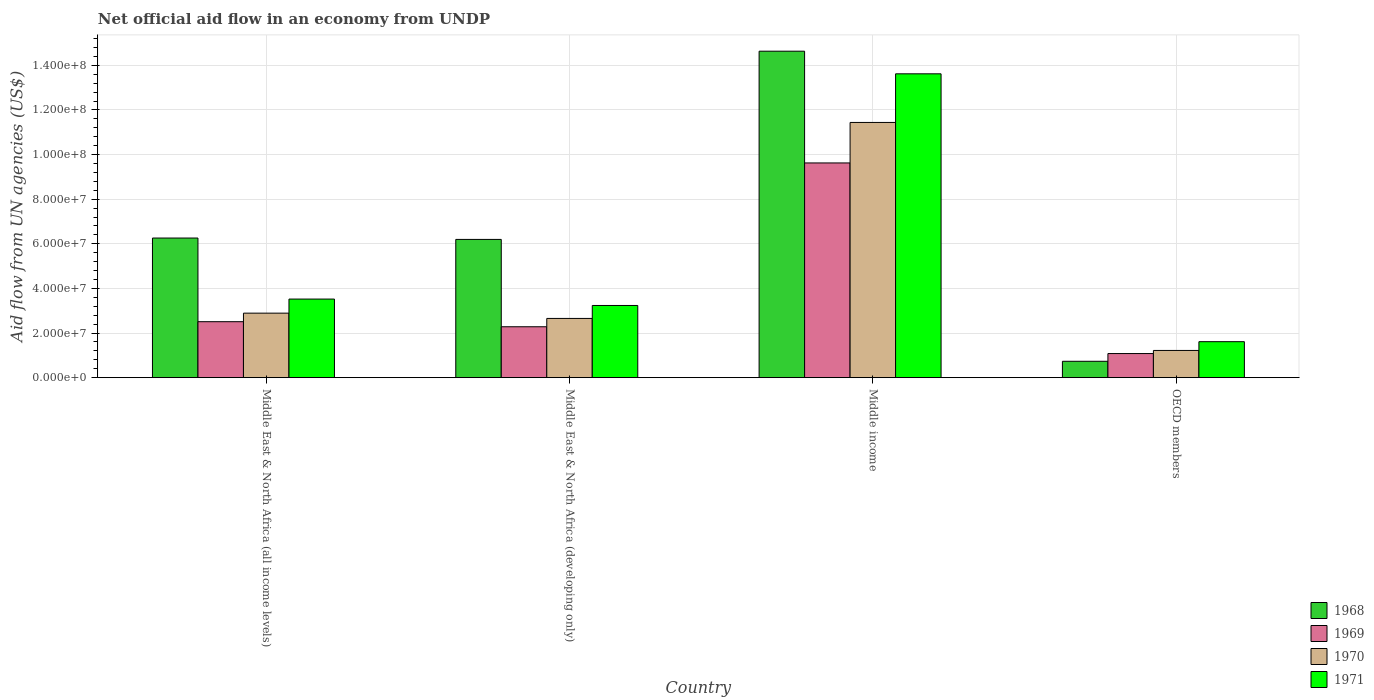How many different coloured bars are there?
Your answer should be compact. 4. Are the number of bars per tick equal to the number of legend labels?
Your answer should be very brief. Yes. How many bars are there on the 3rd tick from the right?
Your answer should be compact. 4. What is the label of the 3rd group of bars from the left?
Your answer should be compact. Middle income. What is the net official aid flow in 1968 in OECD members?
Ensure brevity in your answer.  7.34e+06. Across all countries, what is the maximum net official aid flow in 1969?
Your response must be concise. 9.62e+07. Across all countries, what is the minimum net official aid flow in 1970?
Make the answer very short. 1.22e+07. In which country was the net official aid flow in 1971 minimum?
Make the answer very short. OECD members. What is the total net official aid flow in 1970 in the graph?
Your response must be concise. 1.82e+08. What is the difference between the net official aid flow in 1970 in Middle East & North Africa (all income levels) and that in Middle income?
Provide a succinct answer. -8.55e+07. What is the difference between the net official aid flow in 1968 in Middle East & North Africa (developing only) and the net official aid flow in 1970 in Middle income?
Your answer should be compact. -5.24e+07. What is the average net official aid flow in 1969 per country?
Provide a succinct answer. 3.87e+07. What is the difference between the net official aid flow of/in 1968 and net official aid flow of/in 1970 in Middle East & North Africa (developing only)?
Your response must be concise. 3.54e+07. What is the ratio of the net official aid flow in 1968 in Middle East & North Africa (all income levels) to that in Middle income?
Your answer should be compact. 0.43. Is the net official aid flow in 1968 in Middle income less than that in OECD members?
Your answer should be very brief. No. What is the difference between the highest and the second highest net official aid flow in 1969?
Your answer should be compact. 7.34e+07. What is the difference between the highest and the lowest net official aid flow in 1969?
Make the answer very short. 8.54e+07. Is it the case that in every country, the sum of the net official aid flow in 1970 and net official aid flow in 1971 is greater than the sum of net official aid flow in 1968 and net official aid flow in 1969?
Keep it short and to the point. No. What does the 2nd bar from the left in Middle East & North Africa (developing only) represents?
Offer a very short reply. 1969. What does the 3rd bar from the right in Middle East & North Africa (all income levels) represents?
Your answer should be very brief. 1969. How many bars are there?
Your response must be concise. 16. Are all the bars in the graph horizontal?
Your response must be concise. No. How many countries are there in the graph?
Your answer should be compact. 4. What is the difference between two consecutive major ticks on the Y-axis?
Give a very brief answer. 2.00e+07. Does the graph contain any zero values?
Keep it short and to the point. No. Where does the legend appear in the graph?
Make the answer very short. Bottom right. What is the title of the graph?
Provide a short and direct response. Net official aid flow in an economy from UNDP. What is the label or title of the X-axis?
Make the answer very short. Country. What is the label or title of the Y-axis?
Ensure brevity in your answer.  Aid flow from UN agencies (US$). What is the Aid flow from UN agencies (US$) of 1968 in Middle East & North Africa (all income levels)?
Ensure brevity in your answer.  6.26e+07. What is the Aid flow from UN agencies (US$) of 1969 in Middle East & North Africa (all income levels)?
Your answer should be compact. 2.51e+07. What is the Aid flow from UN agencies (US$) of 1970 in Middle East & North Africa (all income levels)?
Offer a terse response. 2.89e+07. What is the Aid flow from UN agencies (US$) of 1971 in Middle East & North Africa (all income levels)?
Your response must be concise. 3.52e+07. What is the Aid flow from UN agencies (US$) of 1968 in Middle East & North Africa (developing only)?
Keep it short and to the point. 6.20e+07. What is the Aid flow from UN agencies (US$) in 1969 in Middle East & North Africa (developing only)?
Your answer should be compact. 2.28e+07. What is the Aid flow from UN agencies (US$) in 1970 in Middle East & North Africa (developing only)?
Your answer should be very brief. 2.66e+07. What is the Aid flow from UN agencies (US$) of 1971 in Middle East & North Africa (developing only)?
Provide a succinct answer. 3.24e+07. What is the Aid flow from UN agencies (US$) of 1968 in Middle income?
Offer a terse response. 1.46e+08. What is the Aid flow from UN agencies (US$) in 1969 in Middle income?
Make the answer very short. 9.62e+07. What is the Aid flow from UN agencies (US$) of 1970 in Middle income?
Ensure brevity in your answer.  1.14e+08. What is the Aid flow from UN agencies (US$) in 1971 in Middle income?
Offer a very short reply. 1.36e+08. What is the Aid flow from UN agencies (US$) of 1968 in OECD members?
Keep it short and to the point. 7.34e+06. What is the Aid flow from UN agencies (US$) in 1969 in OECD members?
Your response must be concise. 1.08e+07. What is the Aid flow from UN agencies (US$) of 1970 in OECD members?
Your response must be concise. 1.22e+07. What is the Aid flow from UN agencies (US$) in 1971 in OECD members?
Give a very brief answer. 1.61e+07. Across all countries, what is the maximum Aid flow from UN agencies (US$) in 1968?
Your answer should be compact. 1.46e+08. Across all countries, what is the maximum Aid flow from UN agencies (US$) in 1969?
Your answer should be compact. 9.62e+07. Across all countries, what is the maximum Aid flow from UN agencies (US$) of 1970?
Keep it short and to the point. 1.14e+08. Across all countries, what is the maximum Aid flow from UN agencies (US$) of 1971?
Provide a succinct answer. 1.36e+08. Across all countries, what is the minimum Aid flow from UN agencies (US$) of 1968?
Your answer should be compact. 7.34e+06. Across all countries, what is the minimum Aid flow from UN agencies (US$) in 1969?
Give a very brief answer. 1.08e+07. Across all countries, what is the minimum Aid flow from UN agencies (US$) of 1970?
Give a very brief answer. 1.22e+07. Across all countries, what is the minimum Aid flow from UN agencies (US$) of 1971?
Your answer should be very brief. 1.61e+07. What is the total Aid flow from UN agencies (US$) in 1968 in the graph?
Make the answer very short. 2.78e+08. What is the total Aid flow from UN agencies (US$) in 1969 in the graph?
Make the answer very short. 1.55e+08. What is the total Aid flow from UN agencies (US$) of 1970 in the graph?
Offer a terse response. 1.82e+08. What is the total Aid flow from UN agencies (US$) in 1971 in the graph?
Offer a very short reply. 2.20e+08. What is the difference between the Aid flow from UN agencies (US$) in 1968 in Middle East & North Africa (all income levels) and that in Middle East & North Africa (developing only)?
Offer a terse response. 6.20e+05. What is the difference between the Aid flow from UN agencies (US$) in 1969 in Middle East & North Africa (all income levels) and that in Middle East & North Africa (developing only)?
Offer a very short reply. 2.27e+06. What is the difference between the Aid flow from UN agencies (US$) of 1970 in Middle East & North Africa (all income levels) and that in Middle East & North Africa (developing only)?
Your response must be concise. 2.37e+06. What is the difference between the Aid flow from UN agencies (US$) in 1971 in Middle East & North Africa (all income levels) and that in Middle East & North Africa (developing only)?
Your answer should be very brief. 2.87e+06. What is the difference between the Aid flow from UN agencies (US$) of 1968 in Middle East & North Africa (all income levels) and that in Middle income?
Ensure brevity in your answer.  -8.38e+07. What is the difference between the Aid flow from UN agencies (US$) in 1969 in Middle East & North Africa (all income levels) and that in Middle income?
Give a very brief answer. -7.12e+07. What is the difference between the Aid flow from UN agencies (US$) of 1970 in Middle East & North Africa (all income levels) and that in Middle income?
Offer a very short reply. -8.55e+07. What is the difference between the Aid flow from UN agencies (US$) of 1971 in Middle East & North Africa (all income levels) and that in Middle income?
Give a very brief answer. -1.01e+08. What is the difference between the Aid flow from UN agencies (US$) in 1968 in Middle East & North Africa (all income levels) and that in OECD members?
Give a very brief answer. 5.52e+07. What is the difference between the Aid flow from UN agencies (US$) in 1969 in Middle East & North Africa (all income levels) and that in OECD members?
Make the answer very short. 1.43e+07. What is the difference between the Aid flow from UN agencies (US$) of 1970 in Middle East & North Africa (all income levels) and that in OECD members?
Your answer should be very brief. 1.67e+07. What is the difference between the Aid flow from UN agencies (US$) of 1971 in Middle East & North Africa (all income levels) and that in OECD members?
Ensure brevity in your answer.  1.91e+07. What is the difference between the Aid flow from UN agencies (US$) in 1968 in Middle East & North Africa (developing only) and that in Middle income?
Your answer should be compact. -8.44e+07. What is the difference between the Aid flow from UN agencies (US$) in 1969 in Middle East & North Africa (developing only) and that in Middle income?
Your response must be concise. -7.34e+07. What is the difference between the Aid flow from UN agencies (US$) in 1970 in Middle East & North Africa (developing only) and that in Middle income?
Your answer should be very brief. -8.78e+07. What is the difference between the Aid flow from UN agencies (US$) in 1971 in Middle East & North Africa (developing only) and that in Middle income?
Offer a very short reply. -1.04e+08. What is the difference between the Aid flow from UN agencies (US$) of 1968 in Middle East & North Africa (developing only) and that in OECD members?
Your answer should be very brief. 5.46e+07. What is the difference between the Aid flow from UN agencies (US$) of 1969 in Middle East & North Africa (developing only) and that in OECD members?
Provide a short and direct response. 1.20e+07. What is the difference between the Aid flow from UN agencies (US$) in 1970 in Middle East & North Africa (developing only) and that in OECD members?
Provide a short and direct response. 1.44e+07. What is the difference between the Aid flow from UN agencies (US$) in 1971 in Middle East & North Africa (developing only) and that in OECD members?
Provide a short and direct response. 1.62e+07. What is the difference between the Aid flow from UN agencies (US$) of 1968 in Middle income and that in OECD members?
Your answer should be very brief. 1.39e+08. What is the difference between the Aid flow from UN agencies (US$) of 1969 in Middle income and that in OECD members?
Provide a short and direct response. 8.54e+07. What is the difference between the Aid flow from UN agencies (US$) in 1970 in Middle income and that in OECD members?
Your answer should be compact. 1.02e+08. What is the difference between the Aid flow from UN agencies (US$) of 1971 in Middle income and that in OECD members?
Offer a very short reply. 1.20e+08. What is the difference between the Aid flow from UN agencies (US$) in 1968 in Middle East & North Africa (all income levels) and the Aid flow from UN agencies (US$) in 1969 in Middle East & North Africa (developing only)?
Provide a short and direct response. 3.98e+07. What is the difference between the Aid flow from UN agencies (US$) in 1968 in Middle East & North Africa (all income levels) and the Aid flow from UN agencies (US$) in 1970 in Middle East & North Africa (developing only)?
Ensure brevity in your answer.  3.60e+07. What is the difference between the Aid flow from UN agencies (US$) in 1968 in Middle East & North Africa (all income levels) and the Aid flow from UN agencies (US$) in 1971 in Middle East & North Africa (developing only)?
Ensure brevity in your answer.  3.02e+07. What is the difference between the Aid flow from UN agencies (US$) of 1969 in Middle East & North Africa (all income levels) and the Aid flow from UN agencies (US$) of 1970 in Middle East & North Africa (developing only)?
Offer a very short reply. -1.46e+06. What is the difference between the Aid flow from UN agencies (US$) in 1969 in Middle East & North Africa (all income levels) and the Aid flow from UN agencies (US$) in 1971 in Middle East & North Africa (developing only)?
Your answer should be very brief. -7.27e+06. What is the difference between the Aid flow from UN agencies (US$) of 1970 in Middle East & North Africa (all income levels) and the Aid flow from UN agencies (US$) of 1971 in Middle East & North Africa (developing only)?
Offer a terse response. -3.44e+06. What is the difference between the Aid flow from UN agencies (US$) of 1968 in Middle East & North Africa (all income levels) and the Aid flow from UN agencies (US$) of 1969 in Middle income?
Give a very brief answer. -3.37e+07. What is the difference between the Aid flow from UN agencies (US$) of 1968 in Middle East & North Africa (all income levels) and the Aid flow from UN agencies (US$) of 1970 in Middle income?
Make the answer very short. -5.18e+07. What is the difference between the Aid flow from UN agencies (US$) in 1968 in Middle East & North Africa (all income levels) and the Aid flow from UN agencies (US$) in 1971 in Middle income?
Ensure brevity in your answer.  -7.36e+07. What is the difference between the Aid flow from UN agencies (US$) in 1969 in Middle East & North Africa (all income levels) and the Aid flow from UN agencies (US$) in 1970 in Middle income?
Offer a terse response. -8.93e+07. What is the difference between the Aid flow from UN agencies (US$) of 1969 in Middle East & North Africa (all income levels) and the Aid flow from UN agencies (US$) of 1971 in Middle income?
Your answer should be compact. -1.11e+08. What is the difference between the Aid flow from UN agencies (US$) in 1970 in Middle East & North Africa (all income levels) and the Aid flow from UN agencies (US$) in 1971 in Middle income?
Make the answer very short. -1.07e+08. What is the difference between the Aid flow from UN agencies (US$) in 1968 in Middle East & North Africa (all income levels) and the Aid flow from UN agencies (US$) in 1969 in OECD members?
Offer a terse response. 5.18e+07. What is the difference between the Aid flow from UN agencies (US$) in 1968 in Middle East & North Africa (all income levels) and the Aid flow from UN agencies (US$) in 1970 in OECD members?
Give a very brief answer. 5.04e+07. What is the difference between the Aid flow from UN agencies (US$) in 1968 in Middle East & North Africa (all income levels) and the Aid flow from UN agencies (US$) in 1971 in OECD members?
Provide a short and direct response. 4.65e+07. What is the difference between the Aid flow from UN agencies (US$) in 1969 in Middle East & North Africa (all income levels) and the Aid flow from UN agencies (US$) in 1970 in OECD members?
Ensure brevity in your answer.  1.29e+07. What is the difference between the Aid flow from UN agencies (US$) of 1969 in Middle East & North Africa (all income levels) and the Aid flow from UN agencies (US$) of 1971 in OECD members?
Ensure brevity in your answer.  8.96e+06. What is the difference between the Aid flow from UN agencies (US$) of 1970 in Middle East & North Africa (all income levels) and the Aid flow from UN agencies (US$) of 1971 in OECD members?
Offer a terse response. 1.28e+07. What is the difference between the Aid flow from UN agencies (US$) of 1968 in Middle East & North Africa (developing only) and the Aid flow from UN agencies (US$) of 1969 in Middle income?
Offer a terse response. -3.43e+07. What is the difference between the Aid flow from UN agencies (US$) of 1968 in Middle East & North Africa (developing only) and the Aid flow from UN agencies (US$) of 1970 in Middle income?
Ensure brevity in your answer.  -5.24e+07. What is the difference between the Aid flow from UN agencies (US$) in 1968 in Middle East & North Africa (developing only) and the Aid flow from UN agencies (US$) in 1971 in Middle income?
Give a very brief answer. -7.42e+07. What is the difference between the Aid flow from UN agencies (US$) in 1969 in Middle East & North Africa (developing only) and the Aid flow from UN agencies (US$) in 1970 in Middle income?
Offer a very short reply. -9.16e+07. What is the difference between the Aid flow from UN agencies (US$) in 1969 in Middle East & North Africa (developing only) and the Aid flow from UN agencies (US$) in 1971 in Middle income?
Make the answer very short. -1.13e+08. What is the difference between the Aid flow from UN agencies (US$) of 1970 in Middle East & North Africa (developing only) and the Aid flow from UN agencies (US$) of 1971 in Middle income?
Keep it short and to the point. -1.10e+08. What is the difference between the Aid flow from UN agencies (US$) of 1968 in Middle East & North Africa (developing only) and the Aid flow from UN agencies (US$) of 1969 in OECD members?
Offer a very short reply. 5.12e+07. What is the difference between the Aid flow from UN agencies (US$) of 1968 in Middle East & North Africa (developing only) and the Aid flow from UN agencies (US$) of 1970 in OECD members?
Offer a very short reply. 4.98e+07. What is the difference between the Aid flow from UN agencies (US$) in 1968 in Middle East & North Africa (developing only) and the Aid flow from UN agencies (US$) in 1971 in OECD members?
Offer a terse response. 4.58e+07. What is the difference between the Aid flow from UN agencies (US$) in 1969 in Middle East & North Africa (developing only) and the Aid flow from UN agencies (US$) in 1970 in OECD members?
Offer a terse response. 1.06e+07. What is the difference between the Aid flow from UN agencies (US$) in 1969 in Middle East & North Africa (developing only) and the Aid flow from UN agencies (US$) in 1971 in OECD members?
Your answer should be compact. 6.69e+06. What is the difference between the Aid flow from UN agencies (US$) of 1970 in Middle East & North Africa (developing only) and the Aid flow from UN agencies (US$) of 1971 in OECD members?
Your answer should be compact. 1.04e+07. What is the difference between the Aid flow from UN agencies (US$) of 1968 in Middle income and the Aid flow from UN agencies (US$) of 1969 in OECD members?
Offer a terse response. 1.36e+08. What is the difference between the Aid flow from UN agencies (US$) in 1968 in Middle income and the Aid flow from UN agencies (US$) in 1970 in OECD members?
Your answer should be very brief. 1.34e+08. What is the difference between the Aid flow from UN agencies (US$) in 1968 in Middle income and the Aid flow from UN agencies (US$) in 1971 in OECD members?
Provide a short and direct response. 1.30e+08. What is the difference between the Aid flow from UN agencies (US$) in 1969 in Middle income and the Aid flow from UN agencies (US$) in 1970 in OECD members?
Provide a short and direct response. 8.40e+07. What is the difference between the Aid flow from UN agencies (US$) of 1969 in Middle income and the Aid flow from UN agencies (US$) of 1971 in OECD members?
Offer a very short reply. 8.01e+07. What is the difference between the Aid flow from UN agencies (US$) of 1970 in Middle income and the Aid flow from UN agencies (US$) of 1971 in OECD members?
Offer a very short reply. 9.83e+07. What is the average Aid flow from UN agencies (US$) in 1968 per country?
Provide a short and direct response. 6.96e+07. What is the average Aid flow from UN agencies (US$) of 1969 per country?
Ensure brevity in your answer.  3.87e+07. What is the average Aid flow from UN agencies (US$) in 1970 per country?
Provide a short and direct response. 4.55e+07. What is the average Aid flow from UN agencies (US$) of 1971 per country?
Provide a succinct answer. 5.50e+07. What is the difference between the Aid flow from UN agencies (US$) in 1968 and Aid flow from UN agencies (US$) in 1969 in Middle East & North Africa (all income levels)?
Ensure brevity in your answer.  3.75e+07. What is the difference between the Aid flow from UN agencies (US$) of 1968 and Aid flow from UN agencies (US$) of 1970 in Middle East & North Africa (all income levels)?
Offer a very short reply. 3.37e+07. What is the difference between the Aid flow from UN agencies (US$) in 1968 and Aid flow from UN agencies (US$) in 1971 in Middle East & North Africa (all income levels)?
Offer a terse response. 2.74e+07. What is the difference between the Aid flow from UN agencies (US$) of 1969 and Aid flow from UN agencies (US$) of 1970 in Middle East & North Africa (all income levels)?
Offer a terse response. -3.83e+06. What is the difference between the Aid flow from UN agencies (US$) in 1969 and Aid flow from UN agencies (US$) in 1971 in Middle East & North Africa (all income levels)?
Make the answer very short. -1.01e+07. What is the difference between the Aid flow from UN agencies (US$) in 1970 and Aid flow from UN agencies (US$) in 1971 in Middle East & North Africa (all income levels)?
Ensure brevity in your answer.  -6.31e+06. What is the difference between the Aid flow from UN agencies (US$) in 1968 and Aid flow from UN agencies (US$) in 1969 in Middle East & North Africa (developing only)?
Your answer should be compact. 3.92e+07. What is the difference between the Aid flow from UN agencies (US$) in 1968 and Aid flow from UN agencies (US$) in 1970 in Middle East & North Africa (developing only)?
Ensure brevity in your answer.  3.54e+07. What is the difference between the Aid flow from UN agencies (US$) in 1968 and Aid flow from UN agencies (US$) in 1971 in Middle East & North Africa (developing only)?
Give a very brief answer. 2.96e+07. What is the difference between the Aid flow from UN agencies (US$) of 1969 and Aid flow from UN agencies (US$) of 1970 in Middle East & North Africa (developing only)?
Your answer should be compact. -3.73e+06. What is the difference between the Aid flow from UN agencies (US$) of 1969 and Aid flow from UN agencies (US$) of 1971 in Middle East & North Africa (developing only)?
Give a very brief answer. -9.54e+06. What is the difference between the Aid flow from UN agencies (US$) of 1970 and Aid flow from UN agencies (US$) of 1971 in Middle East & North Africa (developing only)?
Your answer should be very brief. -5.81e+06. What is the difference between the Aid flow from UN agencies (US$) in 1968 and Aid flow from UN agencies (US$) in 1969 in Middle income?
Provide a short and direct response. 5.01e+07. What is the difference between the Aid flow from UN agencies (US$) in 1968 and Aid flow from UN agencies (US$) in 1970 in Middle income?
Keep it short and to the point. 3.19e+07. What is the difference between the Aid flow from UN agencies (US$) of 1968 and Aid flow from UN agencies (US$) of 1971 in Middle income?
Give a very brief answer. 1.01e+07. What is the difference between the Aid flow from UN agencies (US$) in 1969 and Aid flow from UN agencies (US$) in 1970 in Middle income?
Keep it short and to the point. -1.82e+07. What is the difference between the Aid flow from UN agencies (US$) in 1969 and Aid flow from UN agencies (US$) in 1971 in Middle income?
Your answer should be very brief. -4.00e+07. What is the difference between the Aid flow from UN agencies (US$) of 1970 and Aid flow from UN agencies (US$) of 1971 in Middle income?
Provide a short and direct response. -2.18e+07. What is the difference between the Aid flow from UN agencies (US$) of 1968 and Aid flow from UN agencies (US$) of 1969 in OECD members?
Provide a short and direct response. -3.47e+06. What is the difference between the Aid flow from UN agencies (US$) of 1968 and Aid flow from UN agencies (US$) of 1970 in OECD members?
Your answer should be compact. -4.86e+06. What is the difference between the Aid flow from UN agencies (US$) in 1968 and Aid flow from UN agencies (US$) in 1971 in OECD members?
Your answer should be compact. -8.79e+06. What is the difference between the Aid flow from UN agencies (US$) in 1969 and Aid flow from UN agencies (US$) in 1970 in OECD members?
Keep it short and to the point. -1.39e+06. What is the difference between the Aid flow from UN agencies (US$) of 1969 and Aid flow from UN agencies (US$) of 1971 in OECD members?
Provide a succinct answer. -5.32e+06. What is the difference between the Aid flow from UN agencies (US$) in 1970 and Aid flow from UN agencies (US$) in 1971 in OECD members?
Provide a succinct answer. -3.93e+06. What is the ratio of the Aid flow from UN agencies (US$) in 1969 in Middle East & North Africa (all income levels) to that in Middle East & North Africa (developing only)?
Make the answer very short. 1.1. What is the ratio of the Aid flow from UN agencies (US$) of 1970 in Middle East & North Africa (all income levels) to that in Middle East & North Africa (developing only)?
Your answer should be compact. 1.09. What is the ratio of the Aid flow from UN agencies (US$) in 1971 in Middle East & North Africa (all income levels) to that in Middle East & North Africa (developing only)?
Keep it short and to the point. 1.09. What is the ratio of the Aid flow from UN agencies (US$) of 1968 in Middle East & North Africa (all income levels) to that in Middle income?
Provide a short and direct response. 0.43. What is the ratio of the Aid flow from UN agencies (US$) of 1969 in Middle East & North Africa (all income levels) to that in Middle income?
Offer a very short reply. 0.26. What is the ratio of the Aid flow from UN agencies (US$) of 1970 in Middle East & North Africa (all income levels) to that in Middle income?
Ensure brevity in your answer.  0.25. What is the ratio of the Aid flow from UN agencies (US$) of 1971 in Middle East & North Africa (all income levels) to that in Middle income?
Offer a very short reply. 0.26. What is the ratio of the Aid flow from UN agencies (US$) of 1968 in Middle East & North Africa (all income levels) to that in OECD members?
Offer a very short reply. 8.53. What is the ratio of the Aid flow from UN agencies (US$) of 1969 in Middle East & North Africa (all income levels) to that in OECD members?
Your response must be concise. 2.32. What is the ratio of the Aid flow from UN agencies (US$) of 1970 in Middle East & North Africa (all income levels) to that in OECD members?
Keep it short and to the point. 2.37. What is the ratio of the Aid flow from UN agencies (US$) of 1971 in Middle East & North Africa (all income levels) to that in OECD members?
Your answer should be very brief. 2.18. What is the ratio of the Aid flow from UN agencies (US$) in 1968 in Middle East & North Africa (developing only) to that in Middle income?
Your answer should be compact. 0.42. What is the ratio of the Aid flow from UN agencies (US$) of 1969 in Middle East & North Africa (developing only) to that in Middle income?
Provide a short and direct response. 0.24. What is the ratio of the Aid flow from UN agencies (US$) of 1970 in Middle East & North Africa (developing only) to that in Middle income?
Offer a very short reply. 0.23. What is the ratio of the Aid flow from UN agencies (US$) of 1971 in Middle East & North Africa (developing only) to that in Middle income?
Keep it short and to the point. 0.24. What is the ratio of the Aid flow from UN agencies (US$) in 1968 in Middle East & North Africa (developing only) to that in OECD members?
Your answer should be very brief. 8.44. What is the ratio of the Aid flow from UN agencies (US$) of 1969 in Middle East & North Africa (developing only) to that in OECD members?
Offer a terse response. 2.11. What is the ratio of the Aid flow from UN agencies (US$) of 1970 in Middle East & North Africa (developing only) to that in OECD members?
Offer a terse response. 2.18. What is the ratio of the Aid flow from UN agencies (US$) of 1971 in Middle East & North Africa (developing only) to that in OECD members?
Make the answer very short. 2.01. What is the ratio of the Aid flow from UN agencies (US$) in 1968 in Middle income to that in OECD members?
Ensure brevity in your answer.  19.94. What is the ratio of the Aid flow from UN agencies (US$) of 1969 in Middle income to that in OECD members?
Your answer should be compact. 8.9. What is the ratio of the Aid flow from UN agencies (US$) of 1970 in Middle income to that in OECD members?
Give a very brief answer. 9.38. What is the ratio of the Aid flow from UN agencies (US$) of 1971 in Middle income to that in OECD members?
Offer a terse response. 8.44. What is the difference between the highest and the second highest Aid flow from UN agencies (US$) in 1968?
Offer a terse response. 8.38e+07. What is the difference between the highest and the second highest Aid flow from UN agencies (US$) in 1969?
Offer a terse response. 7.12e+07. What is the difference between the highest and the second highest Aid flow from UN agencies (US$) in 1970?
Provide a succinct answer. 8.55e+07. What is the difference between the highest and the second highest Aid flow from UN agencies (US$) in 1971?
Offer a very short reply. 1.01e+08. What is the difference between the highest and the lowest Aid flow from UN agencies (US$) of 1968?
Offer a terse response. 1.39e+08. What is the difference between the highest and the lowest Aid flow from UN agencies (US$) of 1969?
Give a very brief answer. 8.54e+07. What is the difference between the highest and the lowest Aid flow from UN agencies (US$) in 1970?
Keep it short and to the point. 1.02e+08. What is the difference between the highest and the lowest Aid flow from UN agencies (US$) of 1971?
Your answer should be very brief. 1.20e+08. 